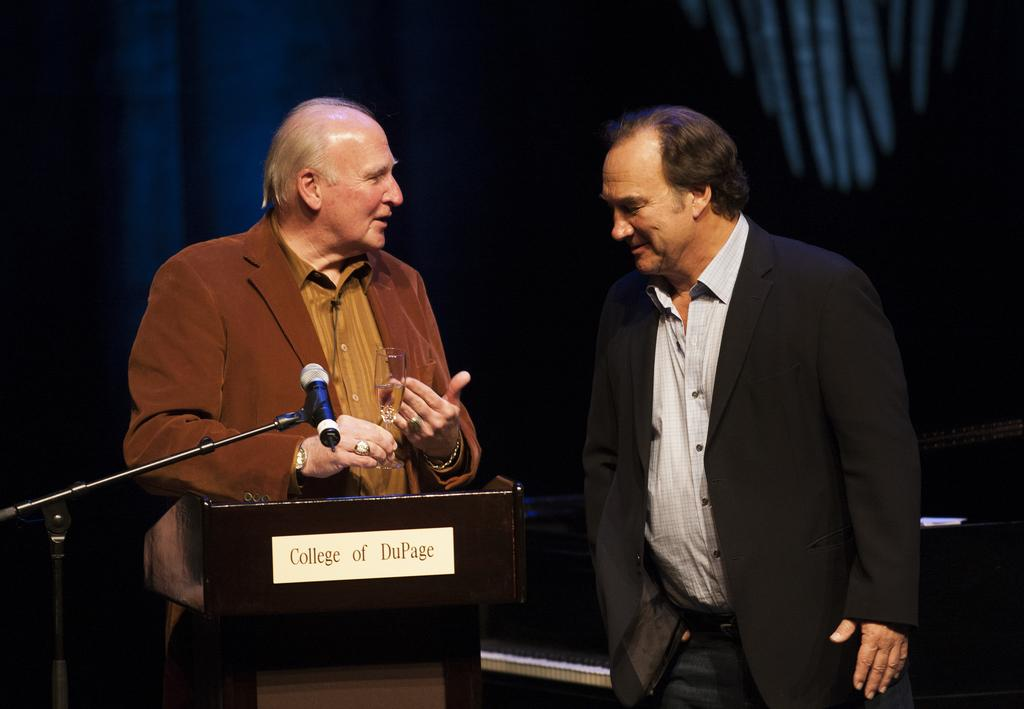How many people are in the image? There are two persons standing near a podium. What are they doing? They are standing near a podium. What object is beside the podium? There is a mic beside the podium. What can be seen in the hands of one of the persons? One person is holding a glass with a drink. What is the color of the background in the image? The background of the image is dark. What type of cactus can be seen in the image? There is no cactus present in the image. How does the person holding the glass with a drink feel about the history of the event? There is no information about the person's feelings or the history of the event in the image. 